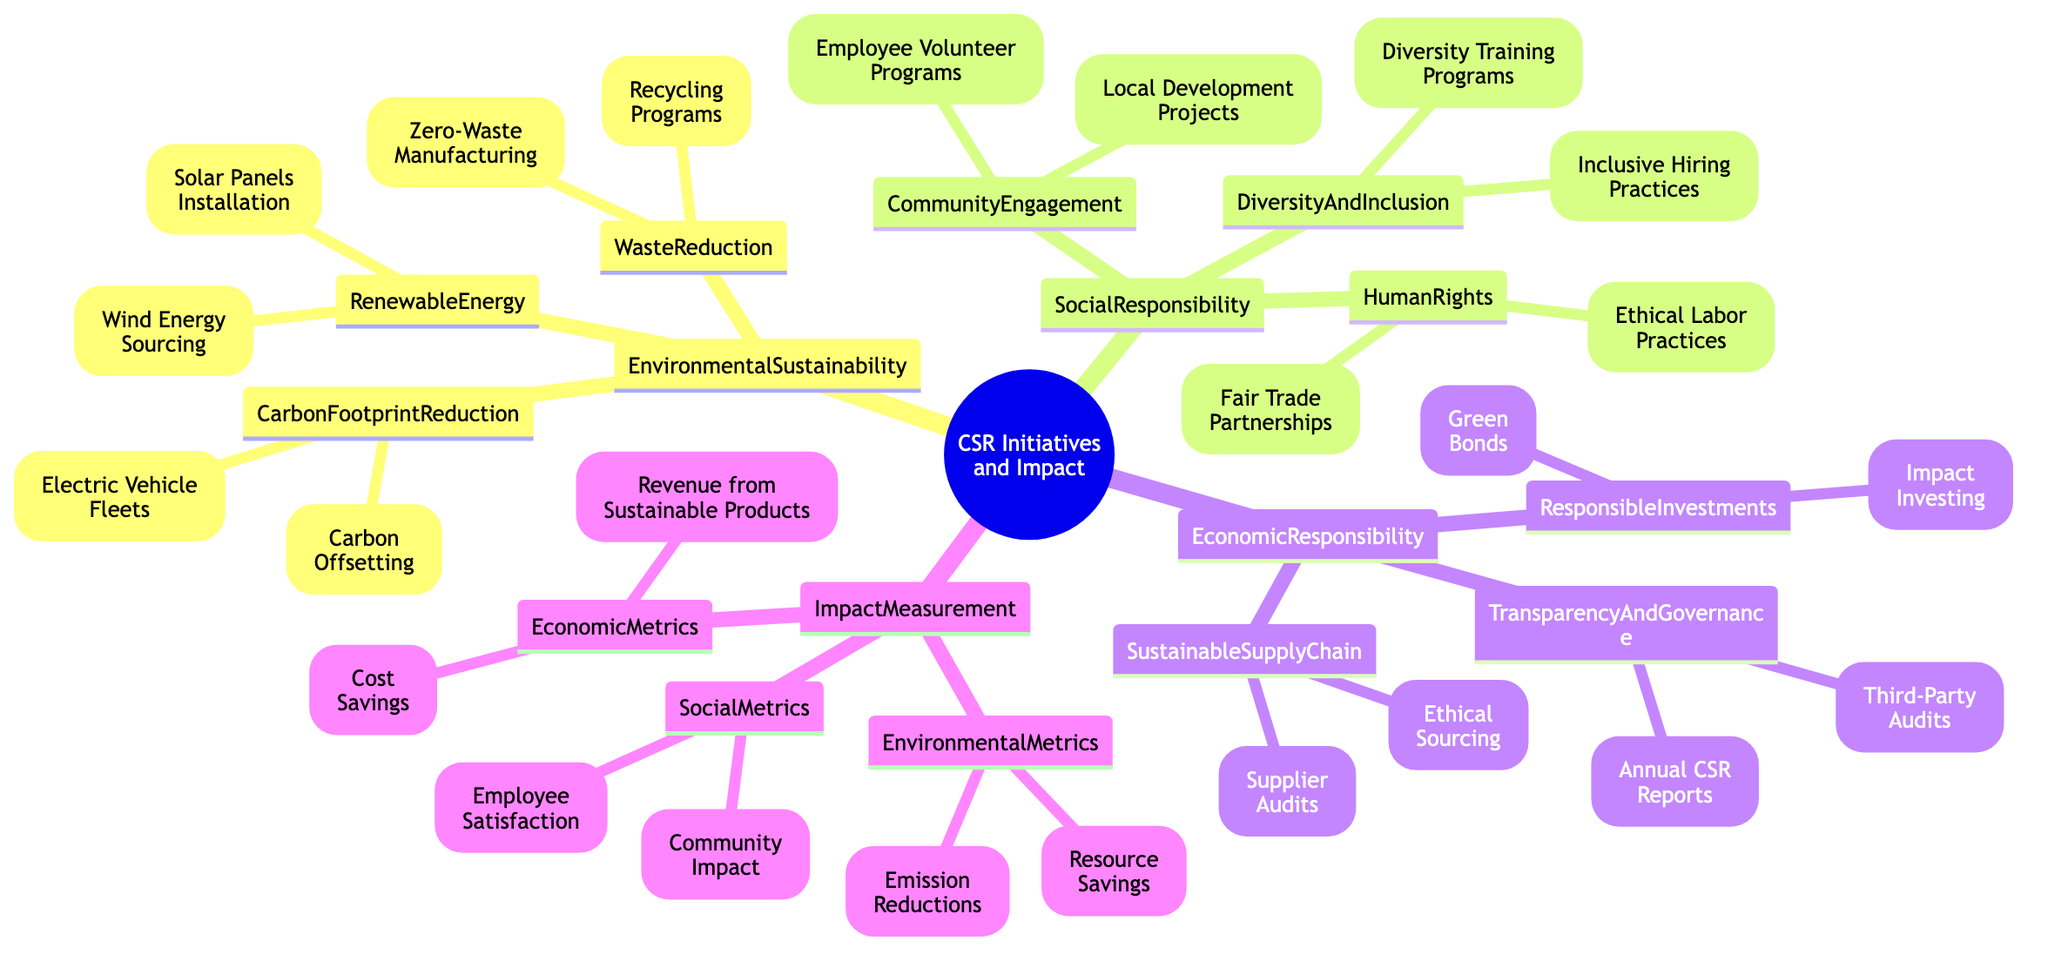What are the two categories under Environmental Sustainability? The diagram shows three main categories under CSR Initiatives and Impact, one of which is Environmental Sustainability. Under this category, two subcategories listed are Renewable Energy and Waste Reduction.
Answer: Renewable Energy, Waste Reduction How many initiatives are listed under Social Responsibility? Under the Social Responsibility category, there are three subcategories: Community Engagement, Diversity and Inclusion, and Human Rights. Each of these subcategories contains two initiatives, which gives a total of 6 initiatives (2 initiatives x 3 subcategories).
Answer: 6 What initiative falls under the Economic Responsibility category? The Economic Responsibility category contains three subcategories: Sustainable Supply Chain, Responsible Investments, and Transparency and Governance. Each subcategory has initiatives listed, such as Ethical Sourcing and Green Bonds. Thus, there are multiple initiatives under Economic Responsibility.
Answer: Ethical Sourcing, Green Bonds Which metric falls under Impact Measurement and relates to the environment? The Impact Measurement category includes Environmental Metrics, Social Metrics, and Economic Metrics. Under Environmental Metrics, one of the listed metrics is Emission Reductions.
Answer: Emission Reductions What is the relationship between Community Engagement and the initiatives listed under it? The diagram specifies that Community Engagement is a subcategory of Social Responsibility. Within the Community Engagement subcategory, there are two specific initiatives: Local Development Projects and Employee Volunteer Programs. Thus, Community Engagement encompasses these two initiatives.
Answer: Local Development Projects, Employee Volunteer Programs How many renewable energy initiatives are mentioned? Under the Environmental Sustainability category, specifically in the Renewable Energy subcategory, there are two initiatives listed: Solar Panels Installation and Wind Energy Sourcing. Therefore, there are a total of two renewable energy initiatives mentioned.
Answer: 2 Which responsibility category includes supplier audits? The Supplier Audits initiative is found under the Sustainable Supply Chain subcategory, which is part of the Economic Responsibility category. This establishes a direct connection between Supplier Audits and Economic Responsibility.
Answer: Economic Responsibility What are the two social metrics related to Impact Measurement? Within the Social Metrics subcategory under Impact Measurement, two metrics are listed: Community Impact and Employee Satisfaction. Thus, these are the two social metrics related to Impact Measurement.
Answer: Community Impact, Employee Satisfaction 